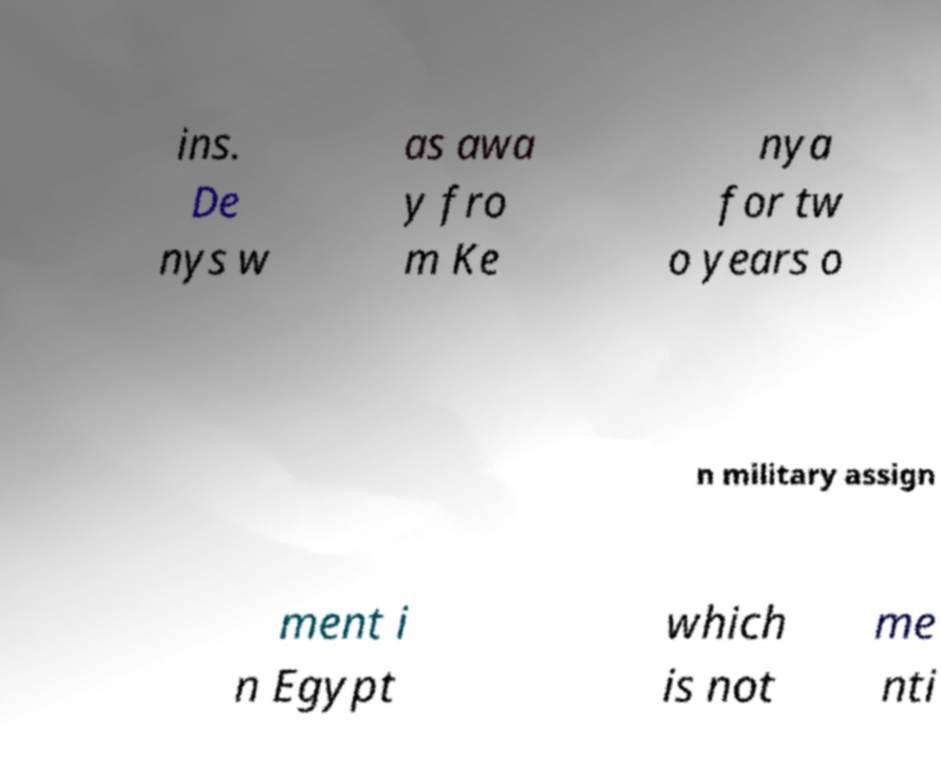There's text embedded in this image that I need extracted. Can you transcribe it verbatim? ins. De nys w as awa y fro m Ke nya for tw o years o n military assign ment i n Egypt which is not me nti 